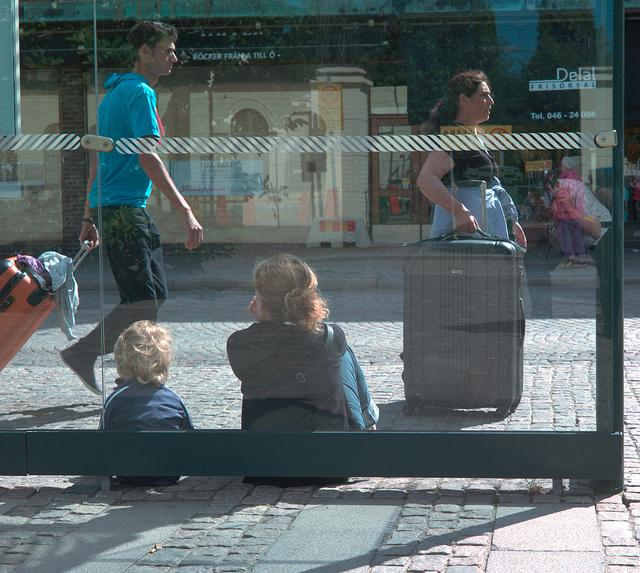Why is the white lines on the glass? Please explain your reasoning. visibility. The white lines assist in visibility of the clear glass pane. 